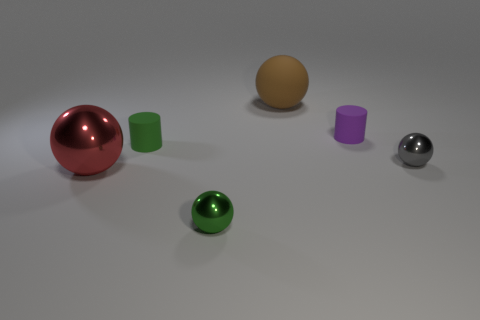Add 1 brown rubber balls. How many objects exist? 7 Subtract all brown balls. How many balls are left? 3 Subtract all green cylinders. How many cylinders are left? 1 Subtract 1 cylinders. How many cylinders are left? 1 Subtract all balls. How many objects are left? 2 Add 4 gray spheres. How many gray spheres are left? 5 Add 4 gray spheres. How many gray spheres exist? 5 Subtract 1 green cylinders. How many objects are left? 5 Subtract all cyan spheres. Subtract all brown cylinders. How many spheres are left? 4 Subtract all tiny gray spheres. Subtract all tiny purple rubber cylinders. How many objects are left? 4 